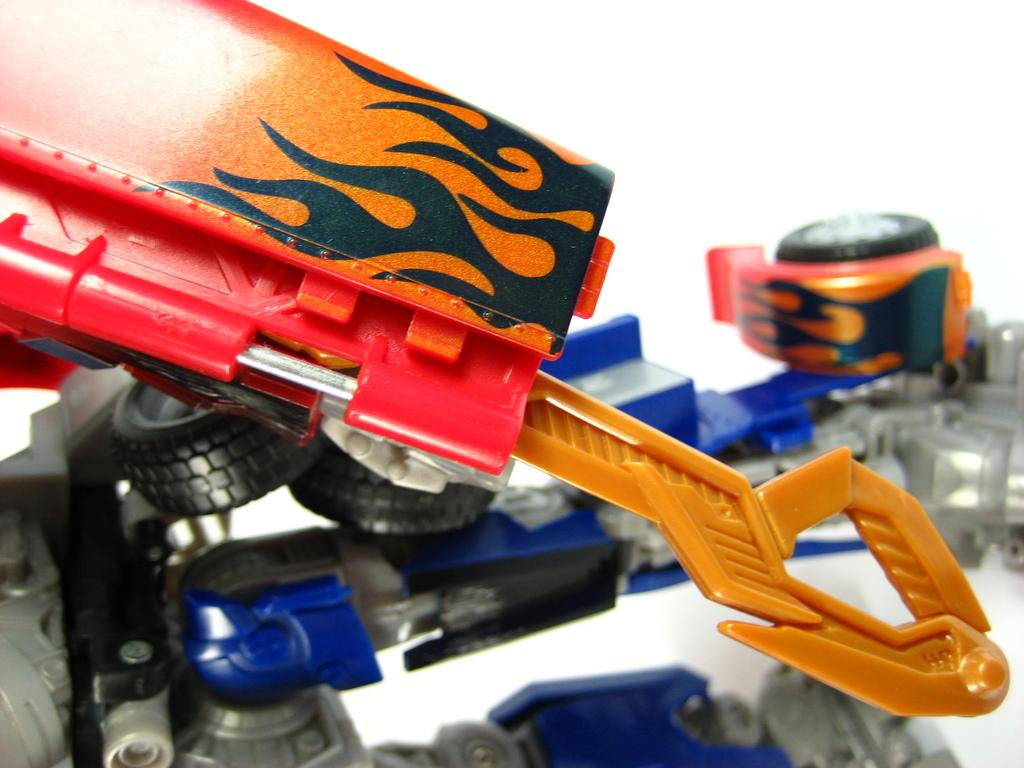What is the main subject in the foreground of the image? There is a toy crane in the foreground of the image. Can you describe the background of the image? The background of the image is white. Are there any other toys visible in the image? Yes, there is another toy in the background of the image. What type of afterthought is depicted in the image? There is no afterthought depicted in the image; it features a toy crane and another toy in a white background. What shape does the process take in the image? The image does not depict a process, but rather a toy crane and another toy in a white background. 